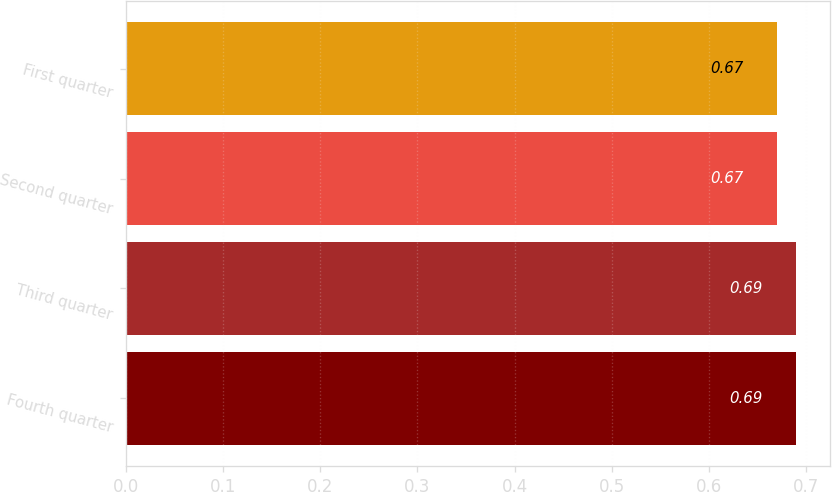Convert chart. <chart><loc_0><loc_0><loc_500><loc_500><bar_chart><fcel>Fourth quarter<fcel>Third quarter<fcel>Second quarter<fcel>First quarter<nl><fcel>0.69<fcel>0.69<fcel>0.67<fcel>0.67<nl></chart> 